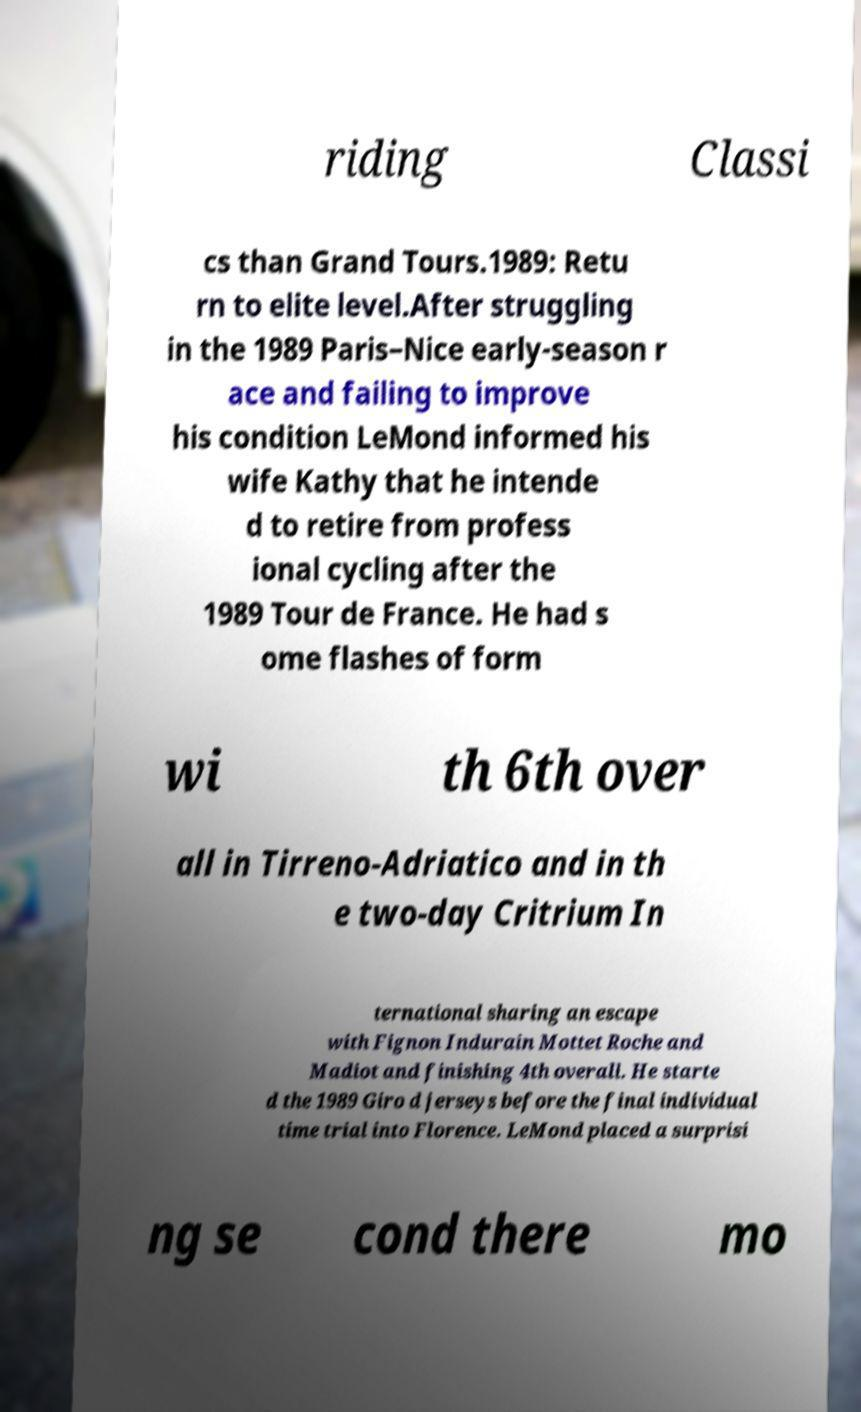For documentation purposes, I need the text within this image transcribed. Could you provide that? riding Classi cs than Grand Tours.1989: Retu rn to elite level.After struggling in the 1989 Paris–Nice early-season r ace and failing to improve his condition LeMond informed his wife Kathy that he intende d to retire from profess ional cycling after the 1989 Tour de France. He had s ome flashes of form wi th 6th over all in Tirreno-Adriatico and in th e two-day Critrium In ternational sharing an escape with Fignon Indurain Mottet Roche and Madiot and finishing 4th overall. He starte d the 1989 Giro d jerseys before the final individual time trial into Florence. LeMond placed a surprisi ng se cond there mo 